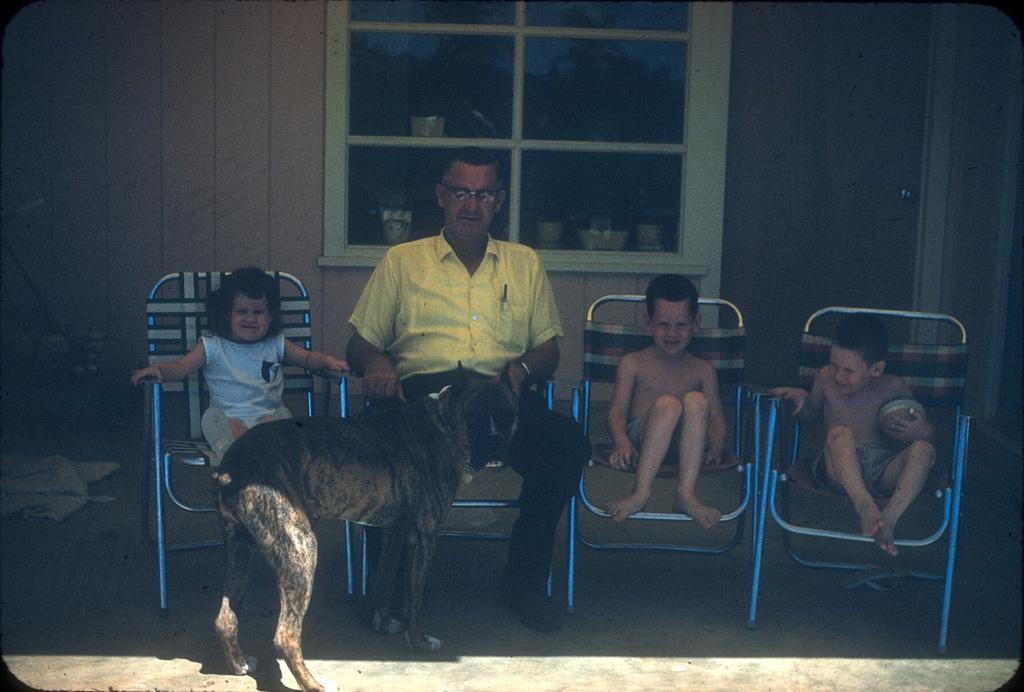Describe this image in one or two sentences. In this picture we can a man and three children sitting on the chairs and in front them there is a dog and behind them there is a window on which some things are placed. 